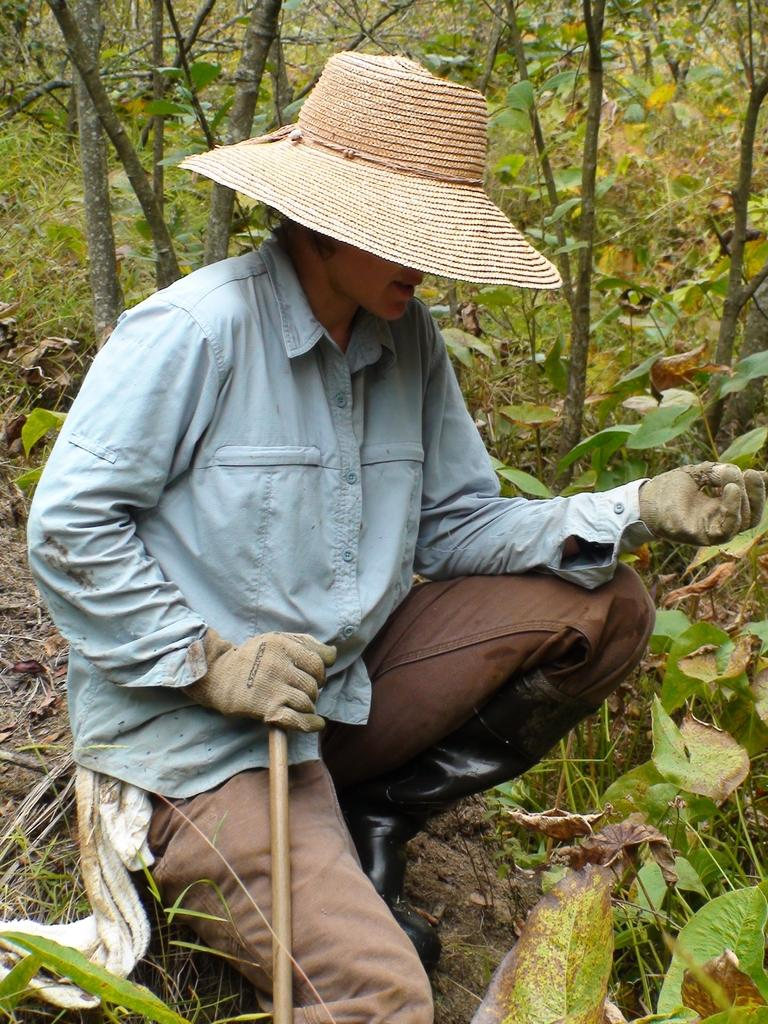What is the main subject of the image? There is a person in the image. What position is the person in? The person is sitting in a squat position. What is the person doing with their hand? The person is catching a stick with one hand. What type of natural environment is visible in the image? There are trees present in the image. What type of account does the person have in the image? There is no mention of an account in the image, as it features a person sitting in a squat position and catching a stick. Can you see any fangs on the person in the image? There are no fangs visible on the person in the image. 